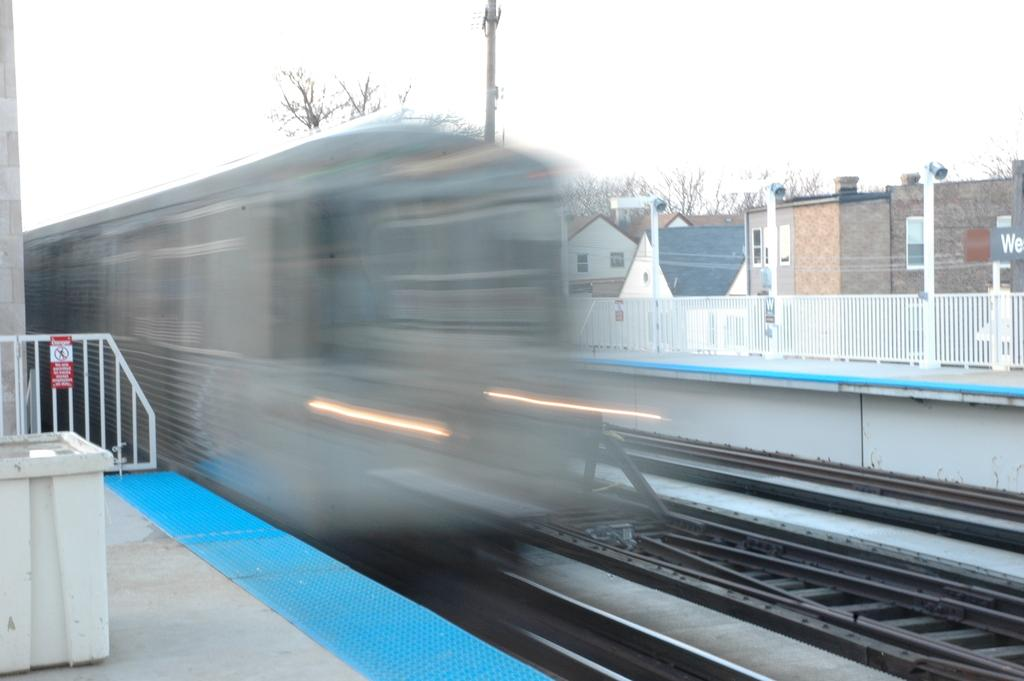What is the main subject of the image? The main subject of the image is a railway track. What can be seen in the background of the image? The background of the image is blue. How many dolls are sitting on the apple in the image? There are no dolls or apples present in the image; it only features a railway track and a blue background. 